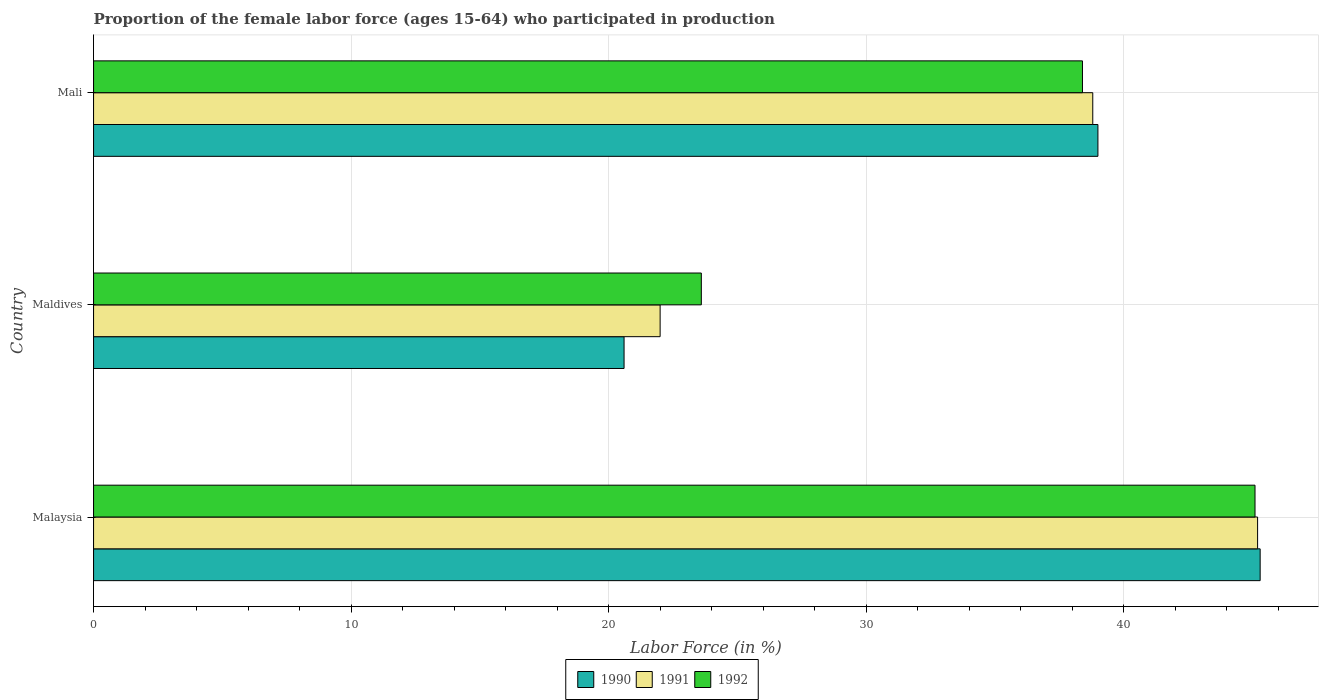How many groups of bars are there?
Your answer should be compact. 3. Are the number of bars per tick equal to the number of legend labels?
Your answer should be very brief. Yes. Are the number of bars on each tick of the Y-axis equal?
Offer a very short reply. Yes. What is the label of the 1st group of bars from the top?
Your answer should be very brief. Mali. In how many cases, is the number of bars for a given country not equal to the number of legend labels?
Give a very brief answer. 0. What is the proportion of the female labor force who participated in production in 1992 in Malaysia?
Ensure brevity in your answer.  45.1. Across all countries, what is the maximum proportion of the female labor force who participated in production in 1992?
Your answer should be very brief. 45.1. Across all countries, what is the minimum proportion of the female labor force who participated in production in 1992?
Make the answer very short. 23.6. In which country was the proportion of the female labor force who participated in production in 1991 maximum?
Provide a succinct answer. Malaysia. In which country was the proportion of the female labor force who participated in production in 1990 minimum?
Make the answer very short. Maldives. What is the total proportion of the female labor force who participated in production in 1992 in the graph?
Keep it short and to the point. 107.1. What is the difference between the proportion of the female labor force who participated in production in 1991 in Malaysia and that in Maldives?
Your answer should be compact. 23.2. What is the difference between the proportion of the female labor force who participated in production in 1991 in Malaysia and the proportion of the female labor force who participated in production in 1992 in Mali?
Keep it short and to the point. 6.8. What is the average proportion of the female labor force who participated in production in 1990 per country?
Give a very brief answer. 34.97. What is the difference between the proportion of the female labor force who participated in production in 1990 and proportion of the female labor force who participated in production in 1991 in Mali?
Make the answer very short. 0.2. What is the ratio of the proportion of the female labor force who participated in production in 1990 in Maldives to that in Mali?
Your response must be concise. 0.53. What is the difference between the highest and the second highest proportion of the female labor force who participated in production in 1992?
Offer a terse response. 6.7. What is the difference between the highest and the lowest proportion of the female labor force who participated in production in 1992?
Keep it short and to the point. 21.5. In how many countries, is the proportion of the female labor force who participated in production in 1991 greater than the average proportion of the female labor force who participated in production in 1991 taken over all countries?
Your answer should be very brief. 2. Are all the bars in the graph horizontal?
Give a very brief answer. Yes. What is the difference between two consecutive major ticks on the X-axis?
Your response must be concise. 10. Does the graph contain grids?
Give a very brief answer. Yes. Where does the legend appear in the graph?
Offer a very short reply. Bottom center. How many legend labels are there?
Give a very brief answer. 3. How are the legend labels stacked?
Offer a very short reply. Horizontal. What is the title of the graph?
Offer a very short reply. Proportion of the female labor force (ages 15-64) who participated in production. What is the Labor Force (in %) in 1990 in Malaysia?
Your answer should be very brief. 45.3. What is the Labor Force (in %) of 1991 in Malaysia?
Provide a succinct answer. 45.2. What is the Labor Force (in %) of 1992 in Malaysia?
Ensure brevity in your answer.  45.1. What is the Labor Force (in %) of 1990 in Maldives?
Give a very brief answer. 20.6. What is the Labor Force (in %) in 1992 in Maldives?
Ensure brevity in your answer.  23.6. What is the Labor Force (in %) of 1990 in Mali?
Provide a succinct answer. 39. What is the Labor Force (in %) in 1991 in Mali?
Keep it short and to the point. 38.8. What is the Labor Force (in %) in 1992 in Mali?
Make the answer very short. 38.4. Across all countries, what is the maximum Labor Force (in %) in 1990?
Your response must be concise. 45.3. Across all countries, what is the maximum Labor Force (in %) of 1991?
Offer a very short reply. 45.2. Across all countries, what is the maximum Labor Force (in %) of 1992?
Keep it short and to the point. 45.1. Across all countries, what is the minimum Labor Force (in %) of 1990?
Your answer should be compact. 20.6. Across all countries, what is the minimum Labor Force (in %) of 1992?
Ensure brevity in your answer.  23.6. What is the total Labor Force (in %) of 1990 in the graph?
Provide a short and direct response. 104.9. What is the total Labor Force (in %) in 1991 in the graph?
Give a very brief answer. 106. What is the total Labor Force (in %) in 1992 in the graph?
Make the answer very short. 107.1. What is the difference between the Labor Force (in %) of 1990 in Malaysia and that in Maldives?
Offer a terse response. 24.7. What is the difference between the Labor Force (in %) in 1991 in Malaysia and that in Maldives?
Make the answer very short. 23.2. What is the difference between the Labor Force (in %) in 1992 in Malaysia and that in Maldives?
Offer a terse response. 21.5. What is the difference between the Labor Force (in %) of 1991 in Malaysia and that in Mali?
Offer a very short reply. 6.4. What is the difference between the Labor Force (in %) in 1990 in Maldives and that in Mali?
Offer a very short reply. -18.4. What is the difference between the Labor Force (in %) in 1991 in Maldives and that in Mali?
Provide a short and direct response. -16.8. What is the difference between the Labor Force (in %) in 1992 in Maldives and that in Mali?
Offer a very short reply. -14.8. What is the difference between the Labor Force (in %) of 1990 in Malaysia and the Labor Force (in %) of 1991 in Maldives?
Offer a very short reply. 23.3. What is the difference between the Labor Force (in %) in 1990 in Malaysia and the Labor Force (in %) in 1992 in Maldives?
Give a very brief answer. 21.7. What is the difference between the Labor Force (in %) in 1991 in Malaysia and the Labor Force (in %) in 1992 in Maldives?
Provide a succinct answer. 21.6. What is the difference between the Labor Force (in %) of 1990 in Maldives and the Labor Force (in %) of 1991 in Mali?
Keep it short and to the point. -18.2. What is the difference between the Labor Force (in %) in 1990 in Maldives and the Labor Force (in %) in 1992 in Mali?
Your answer should be very brief. -17.8. What is the difference between the Labor Force (in %) in 1991 in Maldives and the Labor Force (in %) in 1992 in Mali?
Ensure brevity in your answer.  -16.4. What is the average Labor Force (in %) in 1990 per country?
Give a very brief answer. 34.97. What is the average Labor Force (in %) in 1991 per country?
Your answer should be very brief. 35.33. What is the average Labor Force (in %) of 1992 per country?
Your answer should be very brief. 35.7. What is the difference between the Labor Force (in %) of 1990 and Labor Force (in %) of 1991 in Malaysia?
Your answer should be very brief. 0.1. What is the difference between the Labor Force (in %) in 1990 and Labor Force (in %) in 1992 in Malaysia?
Offer a very short reply. 0.2. What is the difference between the Labor Force (in %) of 1991 and Labor Force (in %) of 1992 in Malaysia?
Make the answer very short. 0.1. What is the difference between the Labor Force (in %) in 1990 and Labor Force (in %) in 1992 in Maldives?
Your answer should be very brief. -3. What is the difference between the Labor Force (in %) in 1990 and Labor Force (in %) in 1992 in Mali?
Offer a terse response. 0.6. What is the difference between the Labor Force (in %) in 1991 and Labor Force (in %) in 1992 in Mali?
Keep it short and to the point. 0.4. What is the ratio of the Labor Force (in %) in 1990 in Malaysia to that in Maldives?
Your answer should be compact. 2.2. What is the ratio of the Labor Force (in %) in 1991 in Malaysia to that in Maldives?
Offer a very short reply. 2.05. What is the ratio of the Labor Force (in %) of 1992 in Malaysia to that in Maldives?
Make the answer very short. 1.91. What is the ratio of the Labor Force (in %) of 1990 in Malaysia to that in Mali?
Your response must be concise. 1.16. What is the ratio of the Labor Force (in %) of 1991 in Malaysia to that in Mali?
Your answer should be very brief. 1.16. What is the ratio of the Labor Force (in %) of 1992 in Malaysia to that in Mali?
Offer a terse response. 1.17. What is the ratio of the Labor Force (in %) in 1990 in Maldives to that in Mali?
Your answer should be very brief. 0.53. What is the ratio of the Labor Force (in %) in 1991 in Maldives to that in Mali?
Make the answer very short. 0.57. What is the ratio of the Labor Force (in %) of 1992 in Maldives to that in Mali?
Keep it short and to the point. 0.61. What is the difference between the highest and the second highest Labor Force (in %) in 1991?
Make the answer very short. 6.4. What is the difference between the highest and the second highest Labor Force (in %) in 1992?
Provide a succinct answer. 6.7. What is the difference between the highest and the lowest Labor Force (in %) of 1990?
Provide a succinct answer. 24.7. What is the difference between the highest and the lowest Labor Force (in %) in 1991?
Ensure brevity in your answer.  23.2. What is the difference between the highest and the lowest Labor Force (in %) of 1992?
Make the answer very short. 21.5. 